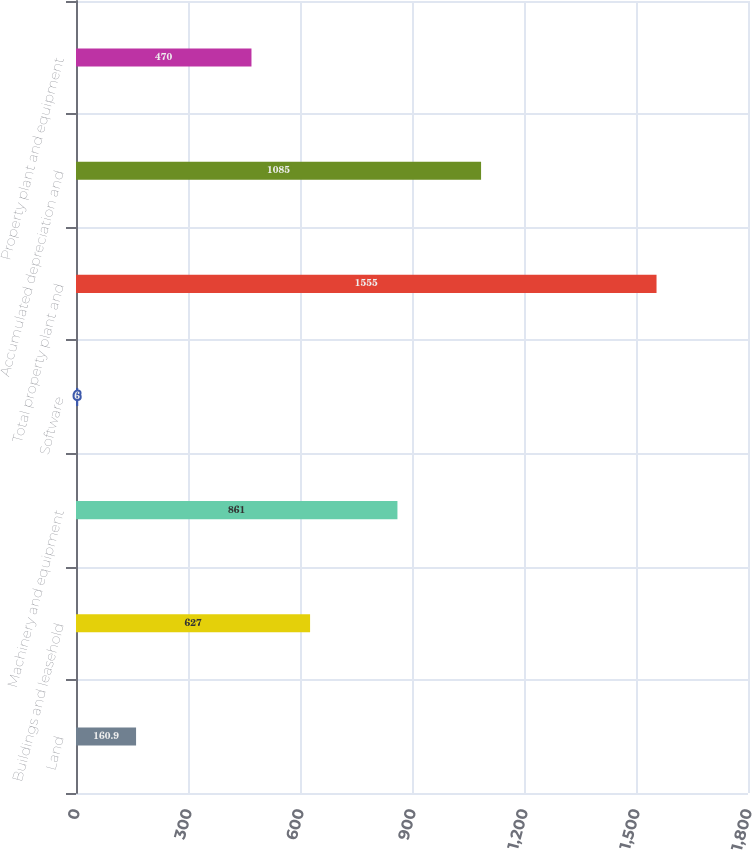Convert chart to OTSL. <chart><loc_0><loc_0><loc_500><loc_500><bar_chart><fcel>Land<fcel>Buildings and leasehold<fcel>Machinery and equipment<fcel>Software<fcel>Total property plant and<fcel>Accumulated depreciation and<fcel>Property plant and equipment<nl><fcel>160.9<fcel>627<fcel>861<fcel>6<fcel>1555<fcel>1085<fcel>470<nl></chart> 